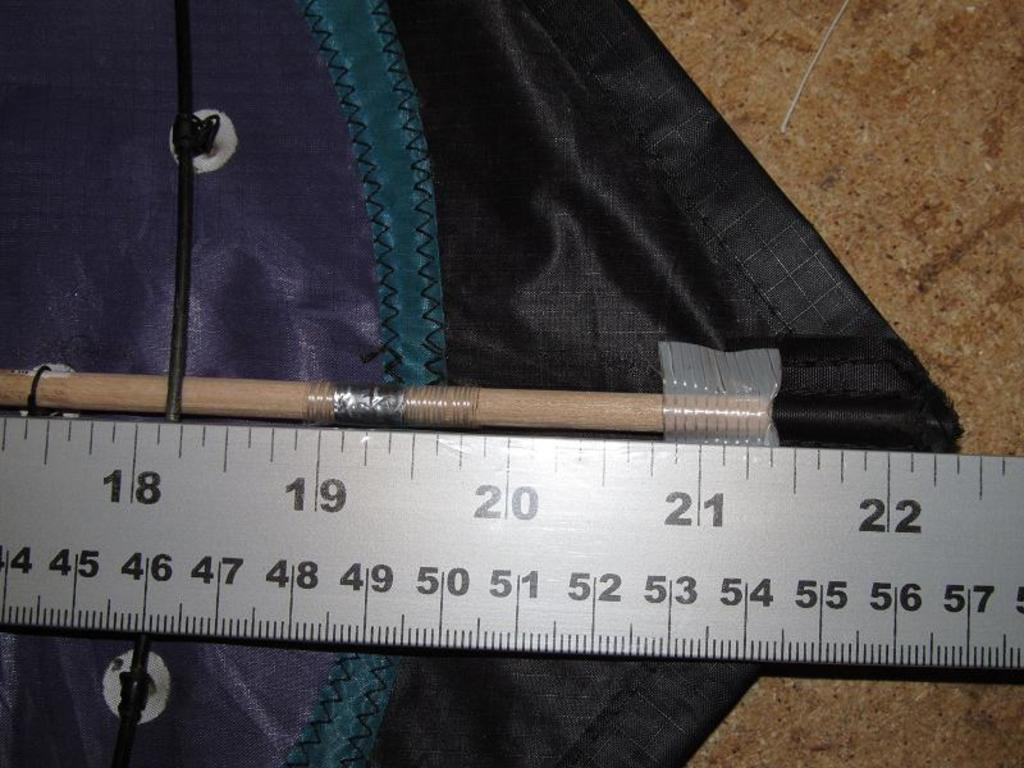<image>
Describe the image concisely. An object is attached to the top of a ruler and ends at 22 inches. 